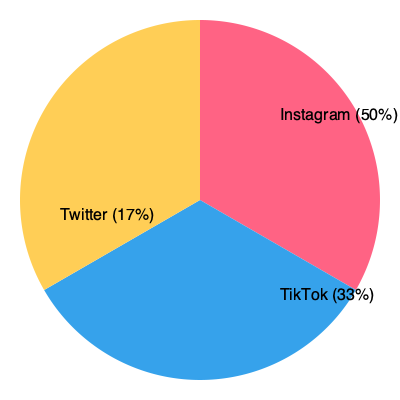Based on the pie chart showing Momin Saqib's social media follower distribution, what percentage of his total followers does he have on Instagram? To determine the percentage of Momin Saqib's followers on Instagram, we need to analyze the pie chart:

1. The pie chart is divided into three sections, representing Instagram, TikTok, and Twitter.
2. Each section's size corresponds to the proportion of followers on that platform.
3. The Instagram section is labeled as 50% of the total.
4. This means that half of Momin Saqib's total social media followers are on Instagram.

Therefore, the percentage of Momin Saqib's total followers on Instagram is 50%.
Answer: 50% 